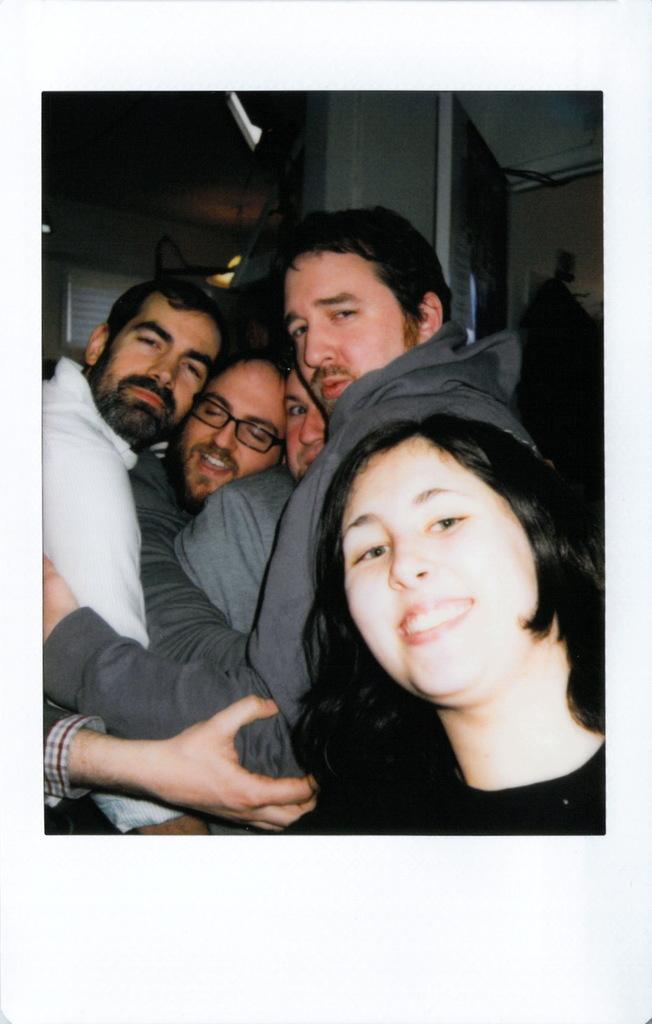How many people are in the image? There is a group of people in the image. Can you describe any specific features of one of the people? One person is wearing spectacles. What is the woman wearing in the image? One woman is wearing a black dress. What can be seen in the background of the image? There are lights and a window visible in the background of the image. What type of copy machine is visible in the image? There is no copy machine present in the image. How does the tramp interact with the people in the image? There is no tramp present in the image; it features a group of people. 